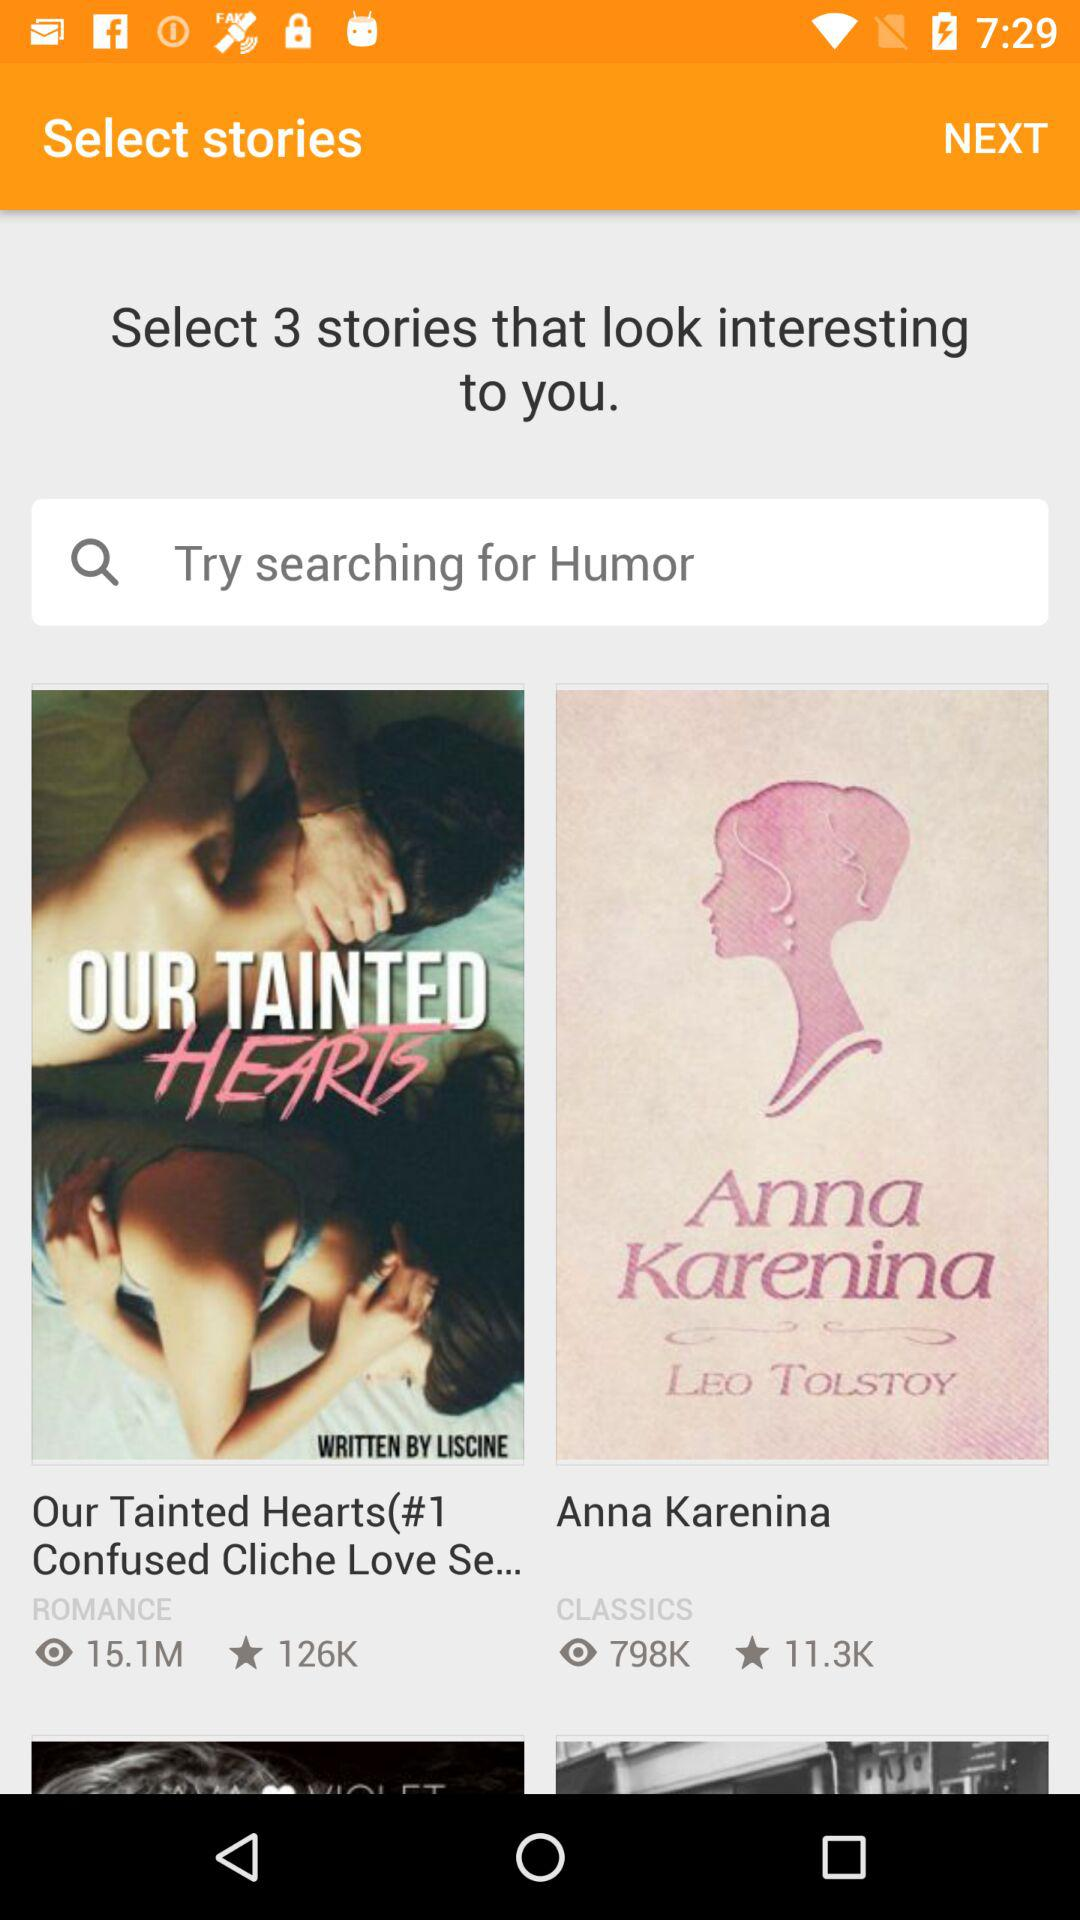Name the story that has the most likes?
When the provided information is insufficient, respond with <no answer>. <no answer> 